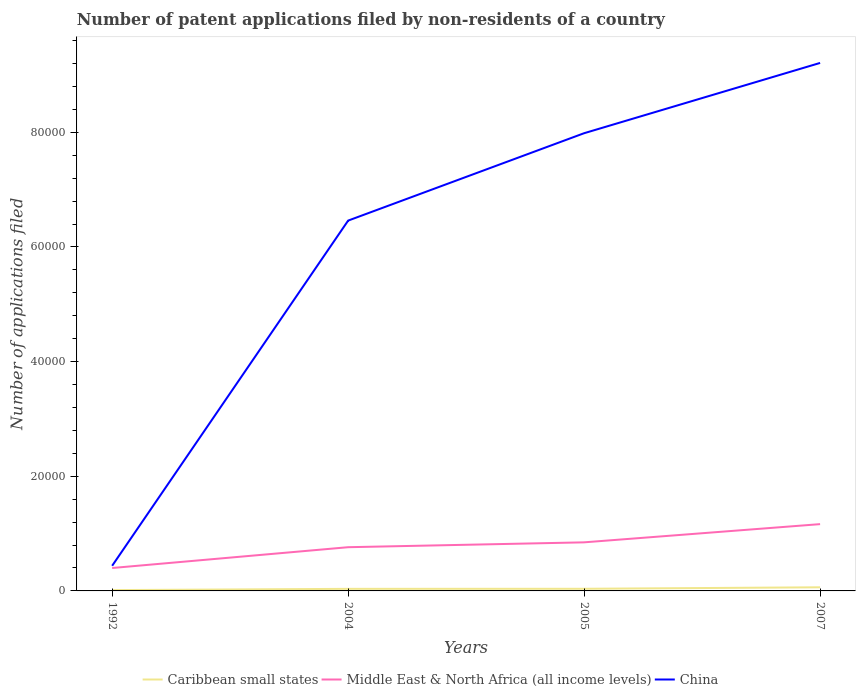Is the number of lines equal to the number of legend labels?
Your response must be concise. Yes. Across all years, what is the maximum number of applications filed in Middle East & North Africa (all income levels)?
Give a very brief answer. 3997. What is the total number of applications filed in Caribbean small states in the graph?
Give a very brief answer. -11. What is the difference between the highest and the second highest number of applications filed in China?
Offer a terse response. 8.77e+04. What is the difference between the highest and the lowest number of applications filed in Middle East & North Africa (all income levels)?
Your response must be concise. 2. Is the number of applications filed in Middle East & North Africa (all income levels) strictly greater than the number of applications filed in Caribbean small states over the years?
Your answer should be very brief. No. Are the values on the major ticks of Y-axis written in scientific E-notation?
Make the answer very short. No. Where does the legend appear in the graph?
Your response must be concise. Bottom center. How many legend labels are there?
Make the answer very short. 3. How are the legend labels stacked?
Keep it short and to the point. Horizontal. What is the title of the graph?
Give a very brief answer. Number of patent applications filed by non-residents of a country. Does "Myanmar" appear as one of the legend labels in the graph?
Give a very brief answer. No. What is the label or title of the X-axis?
Keep it short and to the point. Years. What is the label or title of the Y-axis?
Provide a short and direct response. Number of applications filed. What is the Number of applications filed of Caribbean small states in 1992?
Your response must be concise. 143. What is the Number of applications filed of Middle East & North Africa (all income levels) in 1992?
Ensure brevity in your answer.  3997. What is the Number of applications filed in China in 1992?
Ensure brevity in your answer.  4387. What is the Number of applications filed in Caribbean small states in 2004?
Your answer should be compact. 362. What is the Number of applications filed in Middle East & North Africa (all income levels) in 2004?
Offer a very short reply. 7626. What is the Number of applications filed of China in 2004?
Your answer should be compact. 6.46e+04. What is the Number of applications filed in Caribbean small states in 2005?
Ensure brevity in your answer.  373. What is the Number of applications filed in Middle East & North Africa (all income levels) in 2005?
Offer a very short reply. 8475. What is the Number of applications filed in China in 2005?
Keep it short and to the point. 7.98e+04. What is the Number of applications filed in Caribbean small states in 2007?
Provide a succinct answer. 631. What is the Number of applications filed in Middle East & North Africa (all income levels) in 2007?
Provide a short and direct response. 1.16e+04. What is the Number of applications filed of China in 2007?
Offer a very short reply. 9.21e+04. Across all years, what is the maximum Number of applications filed of Caribbean small states?
Your response must be concise. 631. Across all years, what is the maximum Number of applications filed in Middle East & North Africa (all income levels)?
Give a very brief answer. 1.16e+04. Across all years, what is the maximum Number of applications filed of China?
Your answer should be very brief. 9.21e+04. Across all years, what is the minimum Number of applications filed in Caribbean small states?
Your answer should be very brief. 143. Across all years, what is the minimum Number of applications filed of Middle East & North Africa (all income levels)?
Your answer should be compact. 3997. Across all years, what is the minimum Number of applications filed in China?
Your answer should be compact. 4387. What is the total Number of applications filed of Caribbean small states in the graph?
Provide a short and direct response. 1509. What is the total Number of applications filed in Middle East & North Africa (all income levels) in the graph?
Keep it short and to the point. 3.17e+04. What is the total Number of applications filed in China in the graph?
Keep it short and to the point. 2.41e+05. What is the difference between the Number of applications filed of Caribbean small states in 1992 and that in 2004?
Offer a terse response. -219. What is the difference between the Number of applications filed of Middle East & North Africa (all income levels) in 1992 and that in 2004?
Make the answer very short. -3629. What is the difference between the Number of applications filed of China in 1992 and that in 2004?
Your response must be concise. -6.02e+04. What is the difference between the Number of applications filed in Caribbean small states in 1992 and that in 2005?
Your answer should be compact. -230. What is the difference between the Number of applications filed of Middle East & North Africa (all income levels) in 1992 and that in 2005?
Give a very brief answer. -4478. What is the difference between the Number of applications filed in China in 1992 and that in 2005?
Make the answer very short. -7.55e+04. What is the difference between the Number of applications filed of Caribbean small states in 1992 and that in 2007?
Ensure brevity in your answer.  -488. What is the difference between the Number of applications filed of Middle East & North Africa (all income levels) in 1992 and that in 2007?
Your answer should be very brief. -7653. What is the difference between the Number of applications filed of China in 1992 and that in 2007?
Ensure brevity in your answer.  -8.77e+04. What is the difference between the Number of applications filed of Caribbean small states in 2004 and that in 2005?
Your answer should be compact. -11. What is the difference between the Number of applications filed in Middle East & North Africa (all income levels) in 2004 and that in 2005?
Ensure brevity in your answer.  -849. What is the difference between the Number of applications filed in China in 2004 and that in 2005?
Your answer should be compact. -1.52e+04. What is the difference between the Number of applications filed in Caribbean small states in 2004 and that in 2007?
Your response must be concise. -269. What is the difference between the Number of applications filed of Middle East & North Africa (all income levels) in 2004 and that in 2007?
Offer a very short reply. -4024. What is the difference between the Number of applications filed of China in 2004 and that in 2007?
Provide a succinct answer. -2.75e+04. What is the difference between the Number of applications filed in Caribbean small states in 2005 and that in 2007?
Your response must be concise. -258. What is the difference between the Number of applications filed of Middle East & North Africa (all income levels) in 2005 and that in 2007?
Your answer should be compact. -3175. What is the difference between the Number of applications filed in China in 2005 and that in 2007?
Provide a short and direct response. -1.23e+04. What is the difference between the Number of applications filed of Caribbean small states in 1992 and the Number of applications filed of Middle East & North Africa (all income levels) in 2004?
Give a very brief answer. -7483. What is the difference between the Number of applications filed of Caribbean small states in 1992 and the Number of applications filed of China in 2004?
Offer a terse response. -6.45e+04. What is the difference between the Number of applications filed in Middle East & North Africa (all income levels) in 1992 and the Number of applications filed in China in 2004?
Provide a short and direct response. -6.06e+04. What is the difference between the Number of applications filed of Caribbean small states in 1992 and the Number of applications filed of Middle East & North Africa (all income levels) in 2005?
Ensure brevity in your answer.  -8332. What is the difference between the Number of applications filed of Caribbean small states in 1992 and the Number of applications filed of China in 2005?
Give a very brief answer. -7.97e+04. What is the difference between the Number of applications filed in Middle East & North Africa (all income levels) in 1992 and the Number of applications filed in China in 2005?
Your answer should be compact. -7.58e+04. What is the difference between the Number of applications filed in Caribbean small states in 1992 and the Number of applications filed in Middle East & North Africa (all income levels) in 2007?
Offer a very short reply. -1.15e+04. What is the difference between the Number of applications filed in Caribbean small states in 1992 and the Number of applications filed in China in 2007?
Your answer should be compact. -9.20e+04. What is the difference between the Number of applications filed of Middle East & North Africa (all income levels) in 1992 and the Number of applications filed of China in 2007?
Ensure brevity in your answer.  -8.81e+04. What is the difference between the Number of applications filed of Caribbean small states in 2004 and the Number of applications filed of Middle East & North Africa (all income levels) in 2005?
Offer a terse response. -8113. What is the difference between the Number of applications filed in Caribbean small states in 2004 and the Number of applications filed in China in 2005?
Provide a short and direct response. -7.95e+04. What is the difference between the Number of applications filed of Middle East & North Africa (all income levels) in 2004 and the Number of applications filed of China in 2005?
Provide a succinct answer. -7.22e+04. What is the difference between the Number of applications filed in Caribbean small states in 2004 and the Number of applications filed in Middle East & North Africa (all income levels) in 2007?
Keep it short and to the point. -1.13e+04. What is the difference between the Number of applications filed of Caribbean small states in 2004 and the Number of applications filed of China in 2007?
Ensure brevity in your answer.  -9.17e+04. What is the difference between the Number of applications filed in Middle East & North Africa (all income levels) in 2004 and the Number of applications filed in China in 2007?
Your answer should be compact. -8.45e+04. What is the difference between the Number of applications filed of Caribbean small states in 2005 and the Number of applications filed of Middle East & North Africa (all income levels) in 2007?
Offer a terse response. -1.13e+04. What is the difference between the Number of applications filed of Caribbean small states in 2005 and the Number of applications filed of China in 2007?
Give a very brief answer. -9.17e+04. What is the difference between the Number of applications filed of Middle East & North Africa (all income levels) in 2005 and the Number of applications filed of China in 2007?
Your response must be concise. -8.36e+04. What is the average Number of applications filed in Caribbean small states per year?
Offer a terse response. 377.25. What is the average Number of applications filed in Middle East & North Africa (all income levels) per year?
Provide a short and direct response. 7937. What is the average Number of applications filed of China per year?
Ensure brevity in your answer.  6.02e+04. In the year 1992, what is the difference between the Number of applications filed in Caribbean small states and Number of applications filed in Middle East & North Africa (all income levels)?
Give a very brief answer. -3854. In the year 1992, what is the difference between the Number of applications filed of Caribbean small states and Number of applications filed of China?
Keep it short and to the point. -4244. In the year 1992, what is the difference between the Number of applications filed of Middle East & North Africa (all income levels) and Number of applications filed of China?
Offer a very short reply. -390. In the year 2004, what is the difference between the Number of applications filed of Caribbean small states and Number of applications filed of Middle East & North Africa (all income levels)?
Make the answer very short. -7264. In the year 2004, what is the difference between the Number of applications filed of Caribbean small states and Number of applications filed of China?
Your answer should be compact. -6.42e+04. In the year 2004, what is the difference between the Number of applications filed of Middle East & North Africa (all income levels) and Number of applications filed of China?
Offer a very short reply. -5.70e+04. In the year 2005, what is the difference between the Number of applications filed in Caribbean small states and Number of applications filed in Middle East & North Africa (all income levels)?
Keep it short and to the point. -8102. In the year 2005, what is the difference between the Number of applications filed in Caribbean small states and Number of applications filed in China?
Provide a short and direct response. -7.95e+04. In the year 2005, what is the difference between the Number of applications filed of Middle East & North Africa (all income levels) and Number of applications filed of China?
Your answer should be compact. -7.14e+04. In the year 2007, what is the difference between the Number of applications filed of Caribbean small states and Number of applications filed of Middle East & North Africa (all income levels)?
Offer a terse response. -1.10e+04. In the year 2007, what is the difference between the Number of applications filed in Caribbean small states and Number of applications filed in China?
Offer a very short reply. -9.15e+04. In the year 2007, what is the difference between the Number of applications filed of Middle East & North Africa (all income levels) and Number of applications filed of China?
Ensure brevity in your answer.  -8.05e+04. What is the ratio of the Number of applications filed in Caribbean small states in 1992 to that in 2004?
Your response must be concise. 0.4. What is the ratio of the Number of applications filed in Middle East & North Africa (all income levels) in 1992 to that in 2004?
Ensure brevity in your answer.  0.52. What is the ratio of the Number of applications filed of China in 1992 to that in 2004?
Keep it short and to the point. 0.07. What is the ratio of the Number of applications filed of Caribbean small states in 1992 to that in 2005?
Offer a very short reply. 0.38. What is the ratio of the Number of applications filed in Middle East & North Africa (all income levels) in 1992 to that in 2005?
Your answer should be very brief. 0.47. What is the ratio of the Number of applications filed of China in 1992 to that in 2005?
Provide a short and direct response. 0.05. What is the ratio of the Number of applications filed of Caribbean small states in 1992 to that in 2007?
Offer a terse response. 0.23. What is the ratio of the Number of applications filed of Middle East & North Africa (all income levels) in 1992 to that in 2007?
Offer a terse response. 0.34. What is the ratio of the Number of applications filed of China in 1992 to that in 2007?
Offer a very short reply. 0.05. What is the ratio of the Number of applications filed in Caribbean small states in 2004 to that in 2005?
Your answer should be very brief. 0.97. What is the ratio of the Number of applications filed of Middle East & North Africa (all income levels) in 2004 to that in 2005?
Provide a short and direct response. 0.9. What is the ratio of the Number of applications filed in China in 2004 to that in 2005?
Keep it short and to the point. 0.81. What is the ratio of the Number of applications filed of Caribbean small states in 2004 to that in 2007?
Make the answer very short. 0.57. What is the ratio of the Number of applications filed in Middle East & North Africa (all income levels) in 2004 to that in 2007?
Your response must be concise. 0.65. What is the ratio of the Number of applications filed of China in 2004 to that in 2007?
Offer a terse response. 0.7. What is the ratio of the Number of applications filed of Caribbean small states in 2005 to that in 2007?
Make the answer very short. 0.59. What is the ratio of the Number of applications filed of Middle East & North Africa (all income levels) in 2005 to that in 2007?
Give a very brief answer. 0.73. What is the ratio of the Number of applications filed of China in 2005 to that in 2007?
Your answer should be very brief. 0.87. What is the difference between the highest and the second highest Number of applications filed in Caribbean small states?
Provide a succinct answer. 258. What is the difference between the highest and the second highest Number of applications filed of Middle East & North Africa (all income levels)?
Your answer should be very brief. 3175. What is the difference between the highest and the second highest Number of applications filed in China?
Your response must be concise. 1.23e+04. What is the difference between the highest and the lowest Number of applications filed of Caribbean small states?
Your answer should be compact. 488. What is the difference between the highest and the lowest Number of applications filed in Middle East & North Africa (all income levels)?
Provide a succinct answer. 7653. What is the difference between the highest and the lowest Number of applications filed of China?
Your response must be concise. 8.77e+04. 